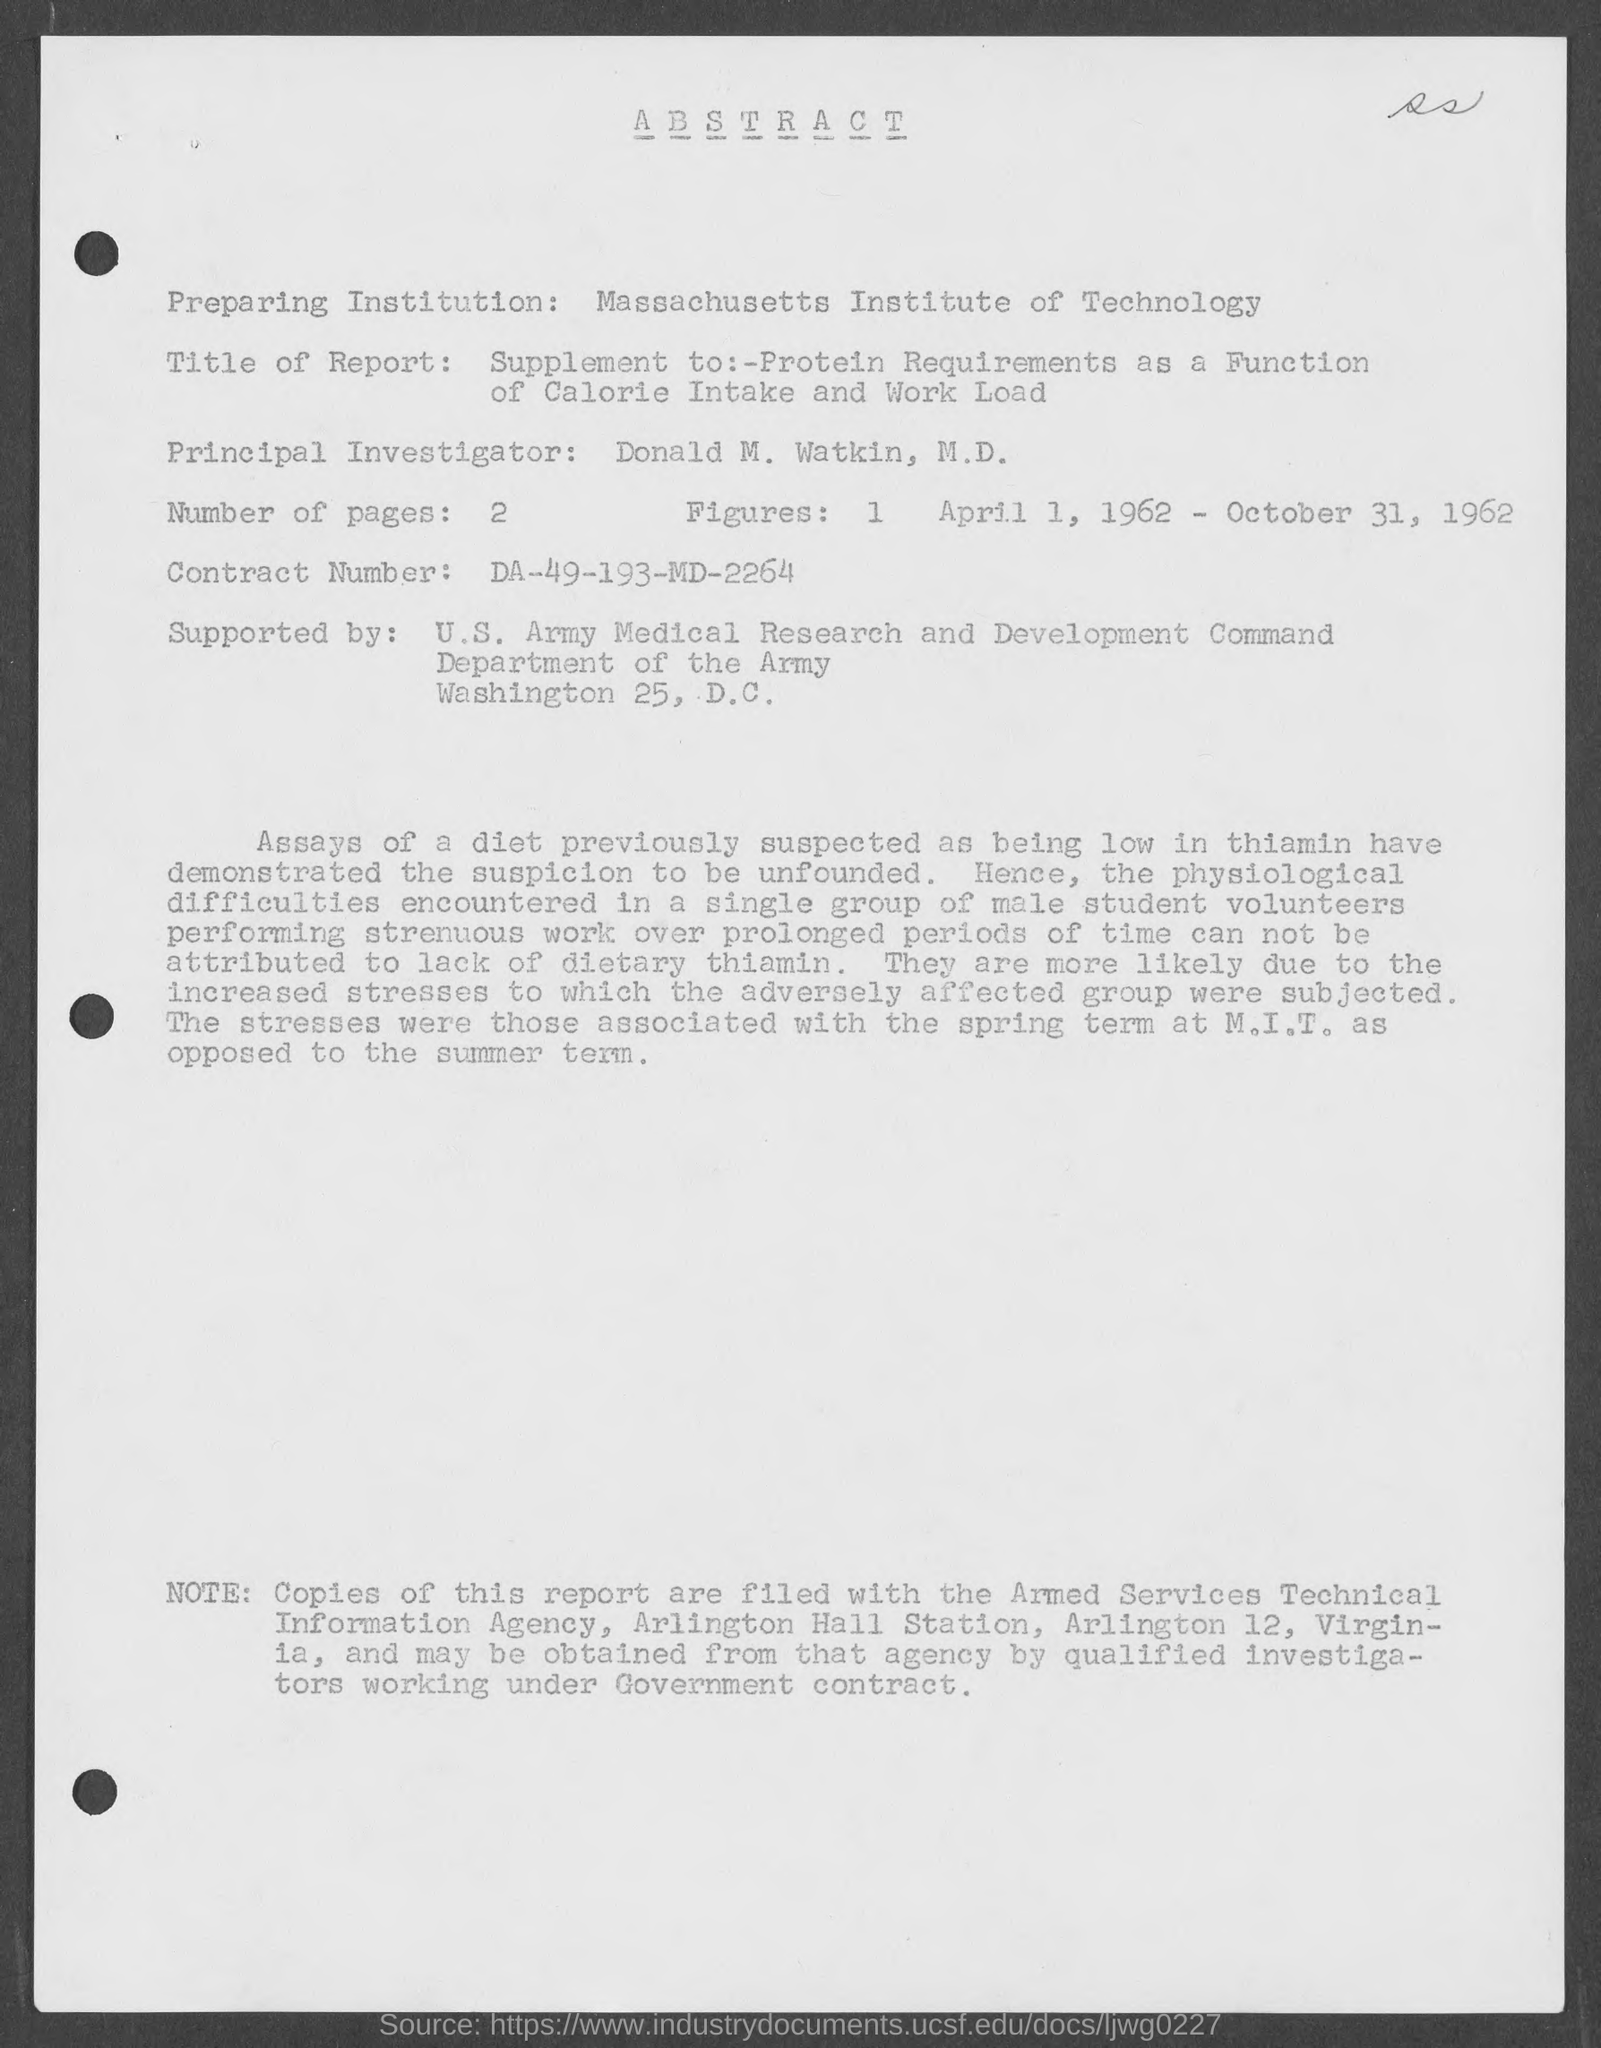Draw attention to some important aspects in this diagram. The U.S. Army Medical Research and Development Command, supported by the Department of the Army, provides medical research and development support. The Principal Investigator is Donald M. Watkin. The Contract Number is DA-49-193-MD-2264. The number of pages is two. The Massachusetts Institute of Technology is a preparing institution. 